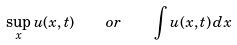Convert formula to latex. <formula><loc_0><loc_0><loc_500><loc_500>\sup _ { x } u ( x , t ) \quad o r \quad \int u ( x , t ) \, d x</formula> 